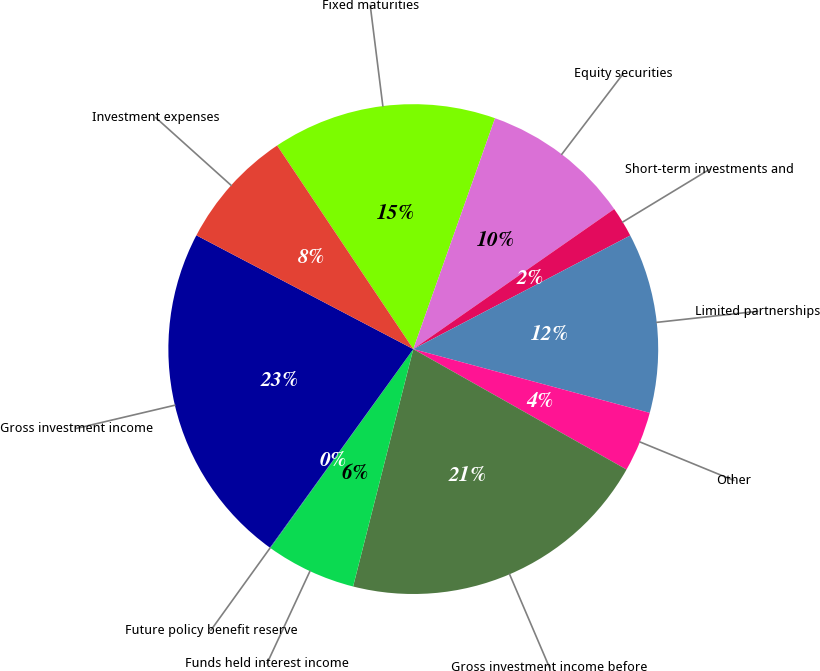<chart> <loc_0><loc_0><loc_500><loc_500><pie_chart><fcel>Fixed maturities<fcel>Equity securities<fcel>Short-term investments and<fcel>Limited partnerships<fcel>Other<fcel>Gross investment income before<fcel>Funds held interest income<fcel>Future policy benefit reserve<fcel>Gross investment income<fcel>Investment expenses<nl><fcel>14.8%<fcel>9.9%<fcel>2.01%<fcel>11.87%<fcel>3.99%<fcel>20.77%<fcel>5.96%<fcel>0.04%<fcel>22.74%<fcel>7.93%<nl></chart> 